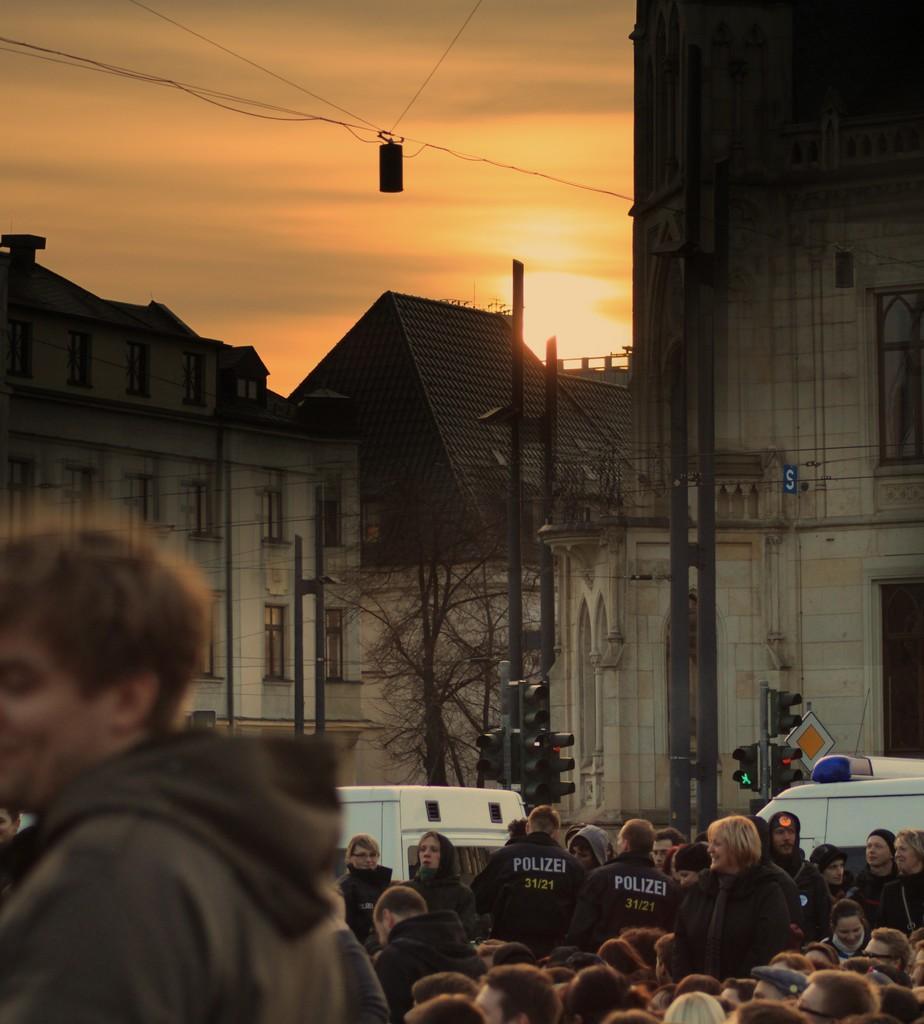In one or two sentences, can you explain what this image depicts? On the left side, there is a person. On the right side, there are persons and vehicles on the road. In the background, there are signal lights attached to the poles, there are buildings, trees, cables and there are clouds in the sky. 